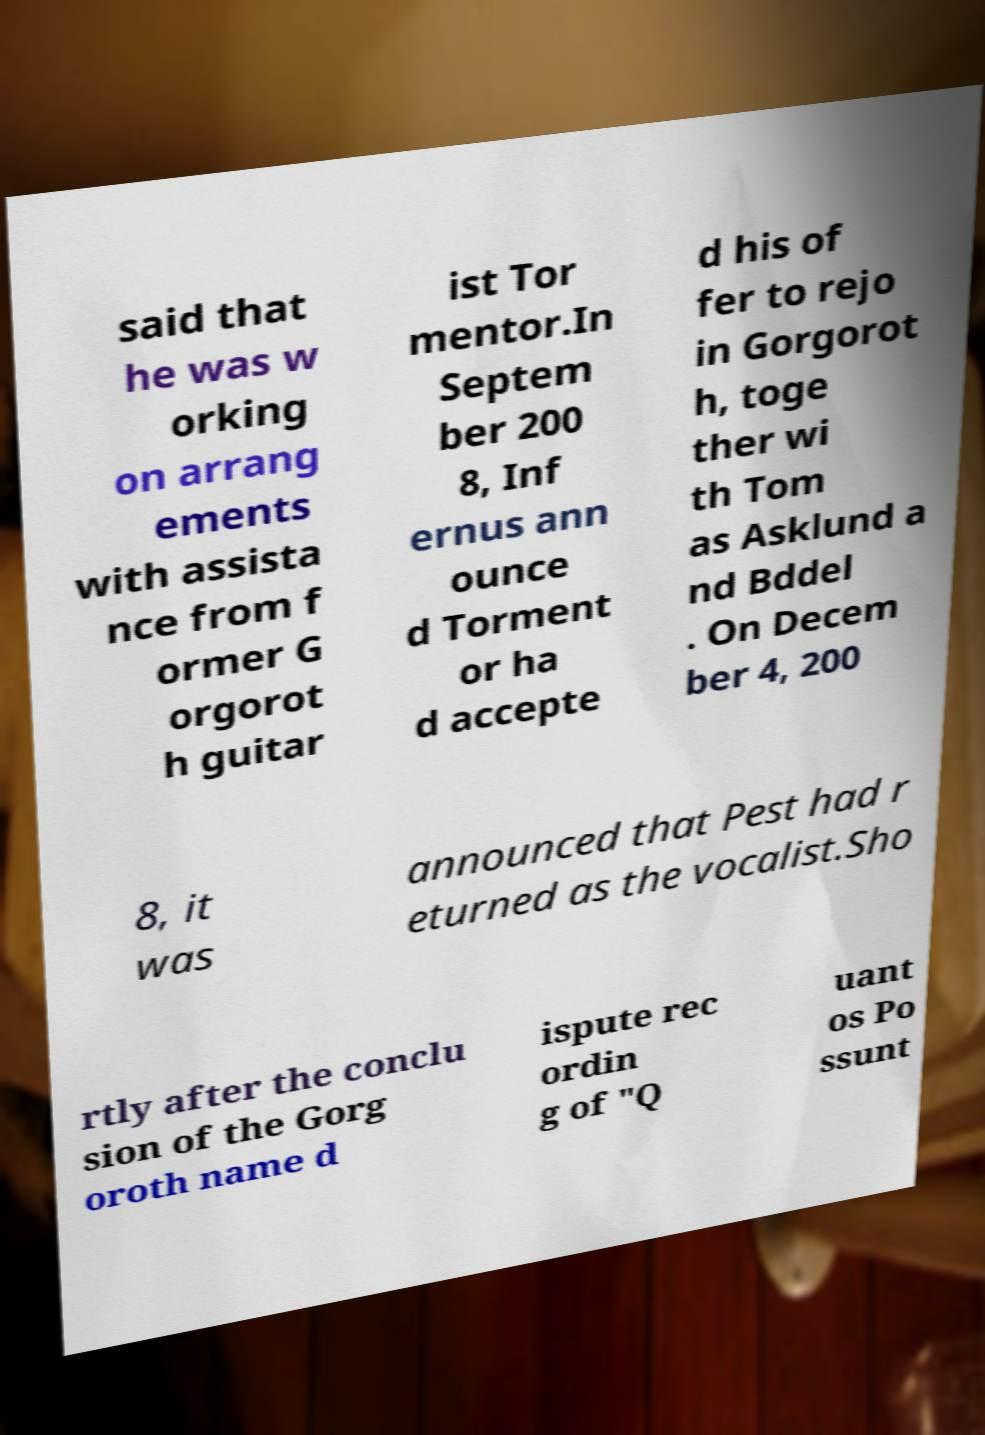Can you accurately transcribe the text from the provided image for me? said that he was w orking on arrang ements with assista nce from f ormer G orgorot h guitar ist Tor mentor.In Septem ber 200 8, Inf ernus ann ounce d Torment or ha d accepte d his of fer to rejo in Gorgorot h, toge ther wi th Tom as Asklund a nd Bddel . On Decem ber 4, 200 8, it was announced that Pest had r eturned as the vocalist.Sho rtly after the conclu sion of the Gorg oroth name d ispute rec ordin g of "Q uant os Po ssunt 